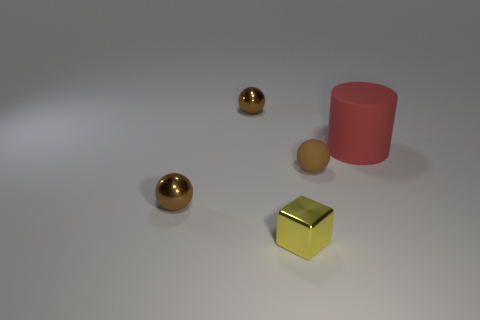What number of brown spheres are both in front of the large red cylinder and to the left of the tiny yellow thing?
Your answer should be compact. 1. The small metallic thing that is behind the brown shiny ball to the left of the tiny ball behind the large matte object is what color?
Ensure brevity in your answer.  Brown. How many tiny brown matte spheres are behind the shiny thing behind the red cylinder?
Keep it short and to the point. 0. What number of other objects are there of the same shape as the large red matte object?
Offer a terse response. 0. What number of objects are yellow metal objects or small brown objects that are behind the tiny brown matte sphere?
Make the answer very short. 2. Is the number of brown metallic objects that are in front of the big red cylinder greater than the number of metallic cubes that are to the right of the small yellow metallic thing?
Your answer should be very brief. Yes. What shape is the rubber thing that is to the right of the tiny brown thing on the right side of the small brown metal thing that is behind the big matte object?
Your answer should be very brief. Cylinder. There is a small brown thing that is in front of the sphere that is right of the yellow metallic block; what is its shape?
Give a very brief answer. Sphere. Are there any other big red objects made of the same material as the large red object?
Your answer should be very brief. No. How many blue things are either cylinders or tiny shiny spheres?
Make the answer very short. 0. 